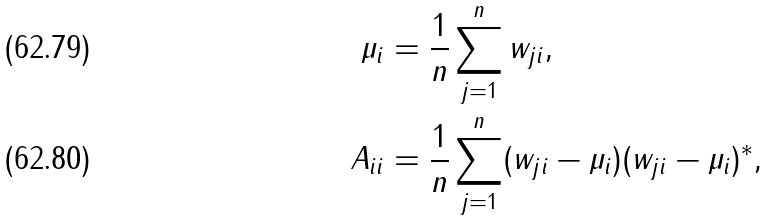Convert formula to latex. <formula><loc_0><loc_0><loc_500><loc_500>\mu _ { i } & = \frac { 1 } { n } \sum _ { j = 1 } ^ { n } w _ { j i } , \\ A _ { i i } & = \frac { 1 } { n } \sum _ { j = 1 } ^ { n } ( w _ { j i } - \mu _ { i } ) ( w _ { j i } - \mu _ { i } ) ^ { * } ,</formula> 